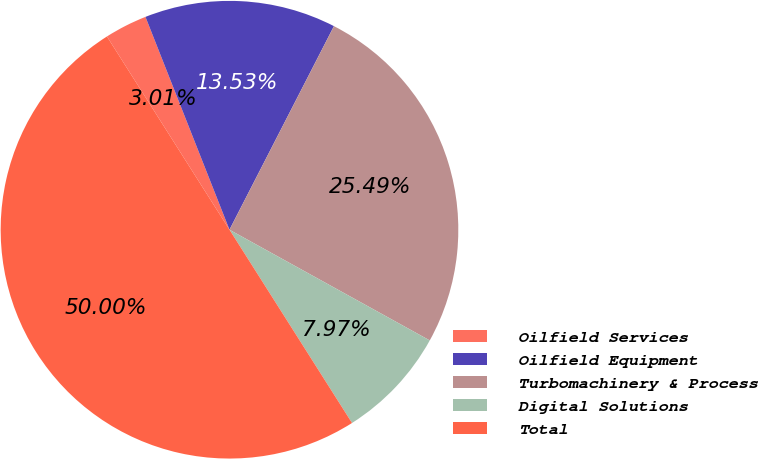Convert chart to OTSL. <chart><loc_0><loc_0><loc_500><loc_500><pie_chart><fcel>Oilfield Services<fcel>Oilfield Equipment<fcel>Turbomachinery & Process<fcel>Digital Solutions<fcel>Total<nl><fcel>3.01%<fcel>13.53%<fcel>25.49%<fcel>7.97%<fcel>50.0%<nl></chart> 